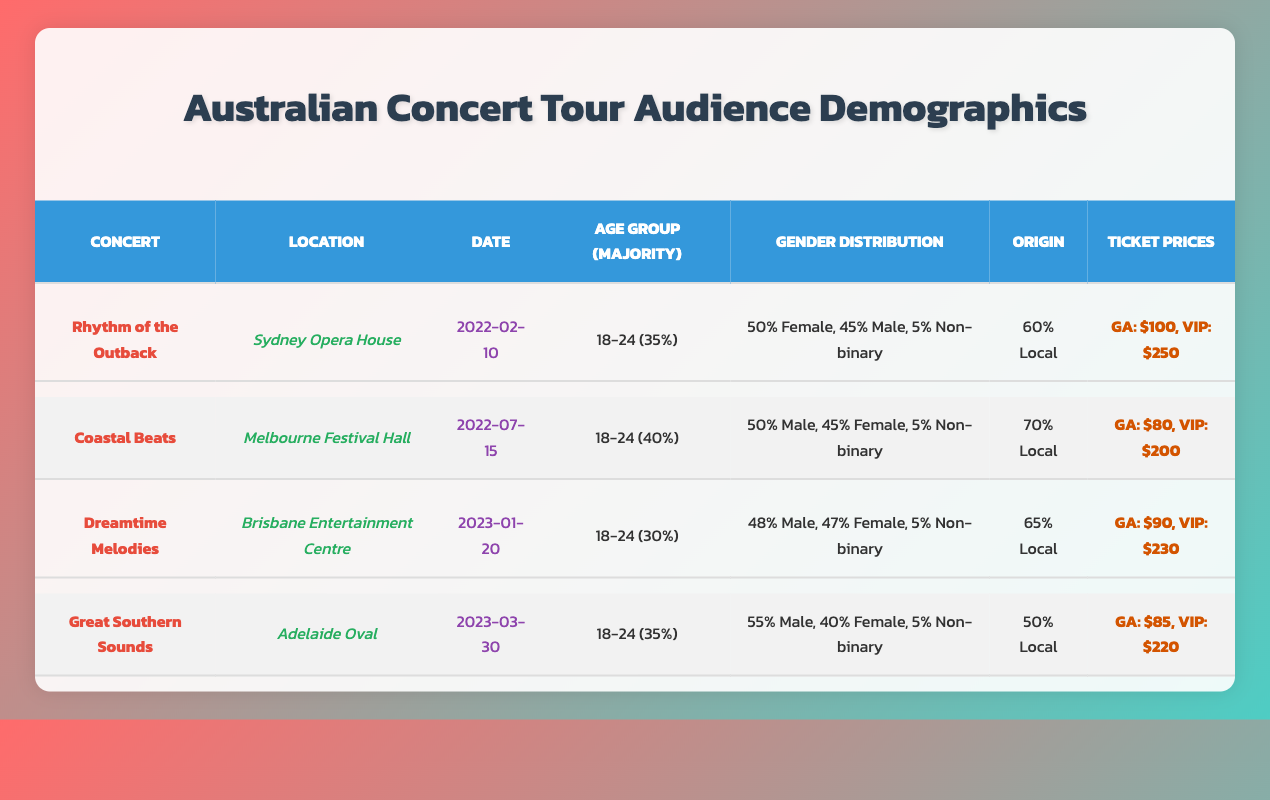What is the concert with the highest percentage of attendees aged 18-24? By examining the age groups for each concert, "Coastal Beats" has 40% of its audience aged 18-24, which is higher than any other concert listed.
Answer: Coastal Beats Which concert had the lowest number of local attendees? Looking at the origin data, "Great Southern Sounds" has 50% local attendees, which is lower than the other concerts' local percentages.
Answer: Great Southern Sounds What is the total number of attendees from the 13-17 age group across all concerts? We sum the 13-17 age group from each concert: 20 (Rhythm of the Outback) + 10 (Coastal Beats) + 15 (Dreamtime Melodies) + 5 (Great Southern Sounds) = 50.
Answer: 50 Are the majority of attendees male in all concerts? By checking the gender distribution, we find that "Rhythm of the Outback," "Coastal Beats," "Dreamtime Melodies," and "Great Southern Sounds" all show either a balanced or female majority, thus majority male is not true for all concerts.
Answer: No What concert had the highest VIP ticket price, and what was that price? By reviewing the ticket prices, "Rhythm of the Outback" has the highest VIP ticket price at $250.
Answer: Rhythm of the Outback, $250 What is the average ticket price for general admission across the concerts? We calculate the average by summing the general admission prices: $100 (Rhythm of the Outback) + $80 (Coastal Beats) + $90 (Dreamtime Melodies) + $85 (Great Southern Sounds) = $355, then divide by 4 concerts, yielding $355/4 = $88.75.
Answer: $88.75 How does the gender distribution of "Dreamtime Melodies" compare to "Great Southern Sounds"? "Dreamtime Melodies" has 48% male and 47% female, while "Great Southern Sounds" has 55% male and 40% female, showing a higher male percentage in Great Southern Sounds.
Answer: Greater male in Great Southern Sounds What percentage of attendees were international for "Rhythm of the Outback"? According to the origin data, 10% of attendees for "Rhythm of the Outback" were international.
Answer: 10% Which concert had a lower percentage of female attendees, "Dreamtime Melodies" or "Great Southern Sounds"? "Dreamtime Melodies" has 47% female attendees while "Great Southern Sounds" has 40% female attendees, making Great Southern Sounds lower in female percentage.
Answer: Great Southern Sounds Is the general admission price for "Coastal Beats" lower than that of "Great Southern Sounds"? The general admission price for "Coastal Beats" is $80, while for "Great Southern Sounds," it is $85, thus it is true that Coastal Beats has a lower price.
Answer: Yes 